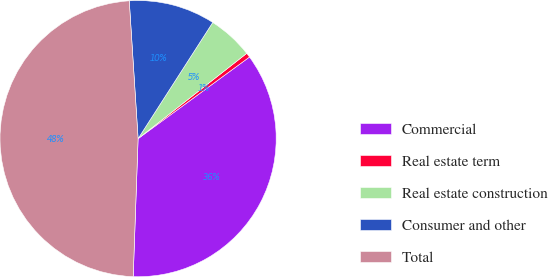Convert chart. <chart><loc_0><loc_0><loc_500><loc_500><pie_chart><fcel>Commercial<fcel>Real estate term<fcel>Real estate construction<fcel>Consumer and other<fcel>Total<nl><fcel>35.63%<fcel>0.53%<fcel>5.32%<fcel>10.11%<fcel>48.42%<nl></chart> 